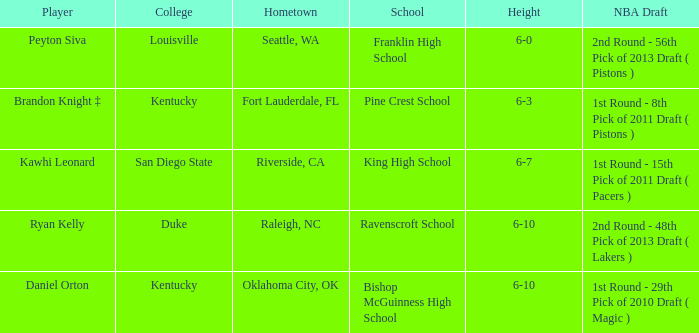Which college does Peyton Siva play for? Louisville. 